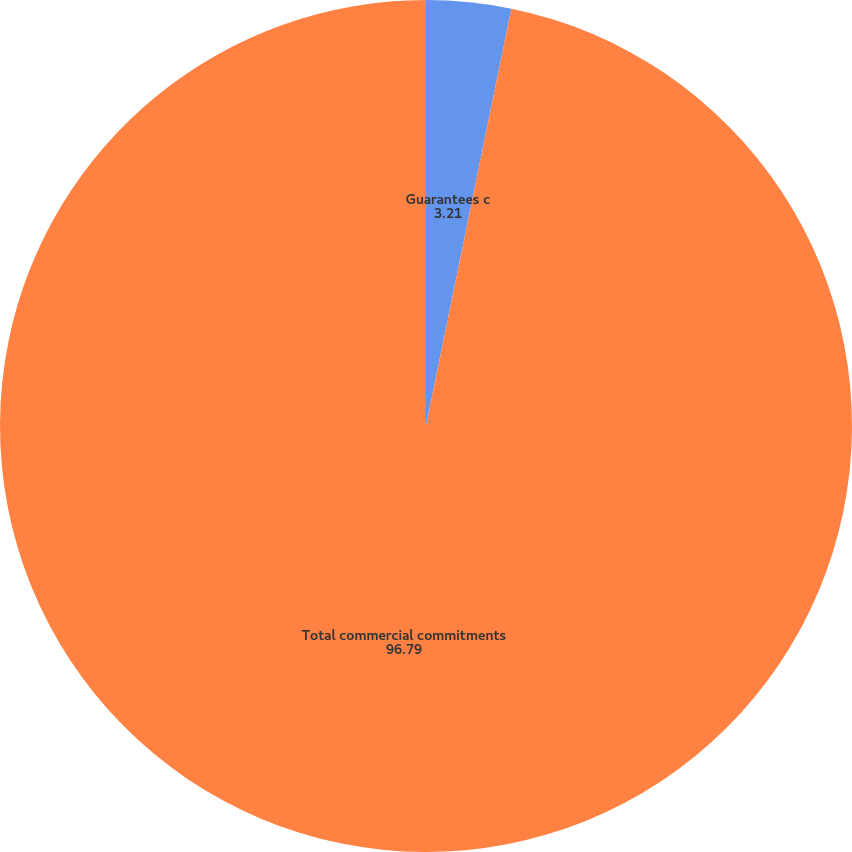Convert chart. <chart><loc_0><loc_0><loc_500><loc_500><pie_chart><fcel>Guarantees c<fcel>Total commercial commitments<nl><fcel>3.21%<fcel>96.79%<nl></chart> 